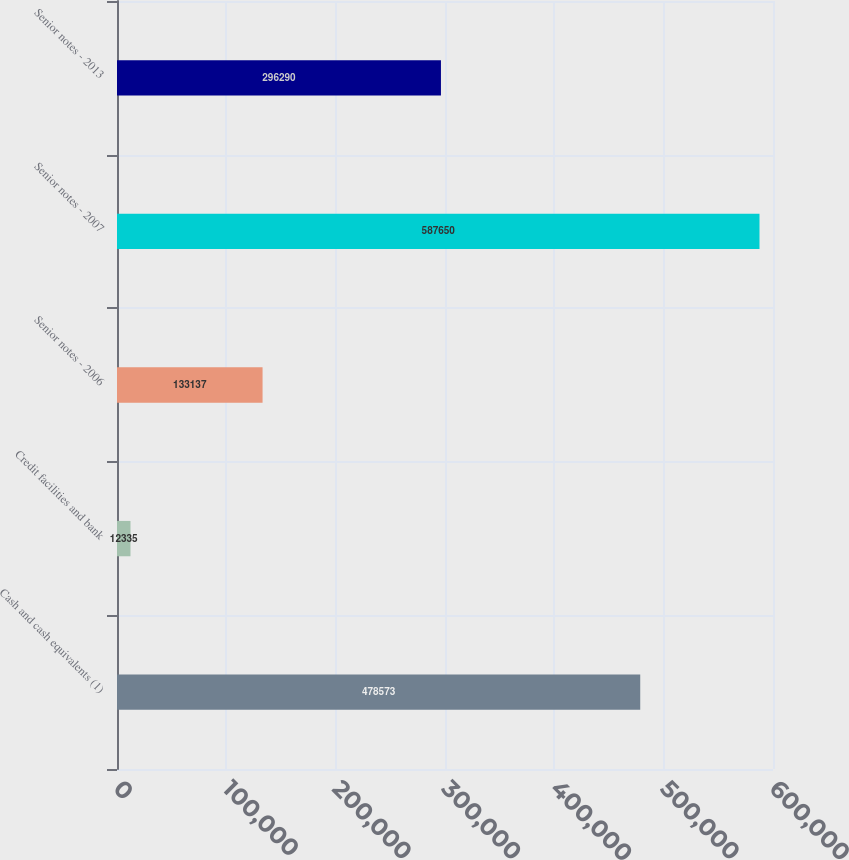Convert chart to OTSL. <chart><loc_0><loc_0><loc_500><loc_500><bar_chart><fcel>Cash and cash equivalents (1)<fcel>Credit facilities and bank<fcel>Senior notes - 2006<fcel>Senior notes - 2007<fcel>Senior notes - 2013<nl><fcel>478573<fcel>12335<fcel>133137<fcel>587650<fcel>296290<nl></chart> 